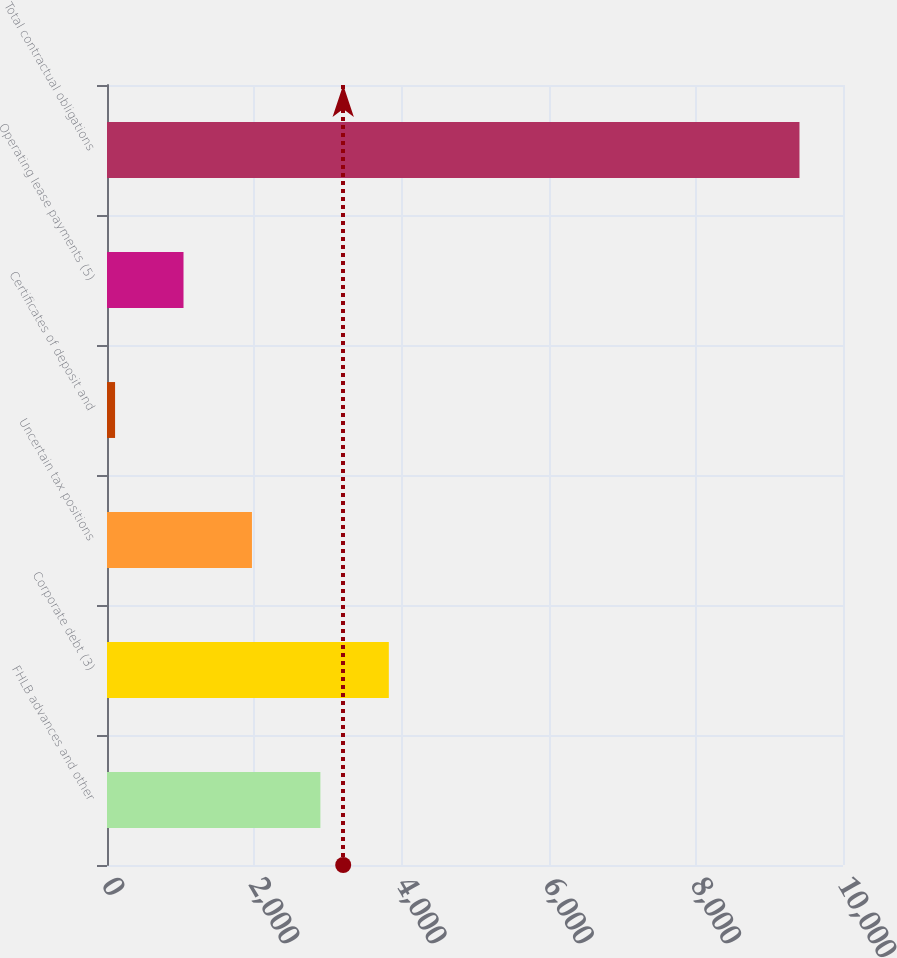Convert chart. <chart><loc_0><loc_0><loc_500><loc_500><bar_chart><fcel>FHLB advances and other<fcel>Corporate debt (3)<fcel>Uncertain tax positions<fcel>Certificates of deposit and<fcel>Operating lease payments (5)<fcel>Total contractual obligations<nl><fcel>2899.37<fcel>3829.26<fcel>1969.48<fcel>109.7<fcel>1039.59<fcel>9408.6<nl></chart> 